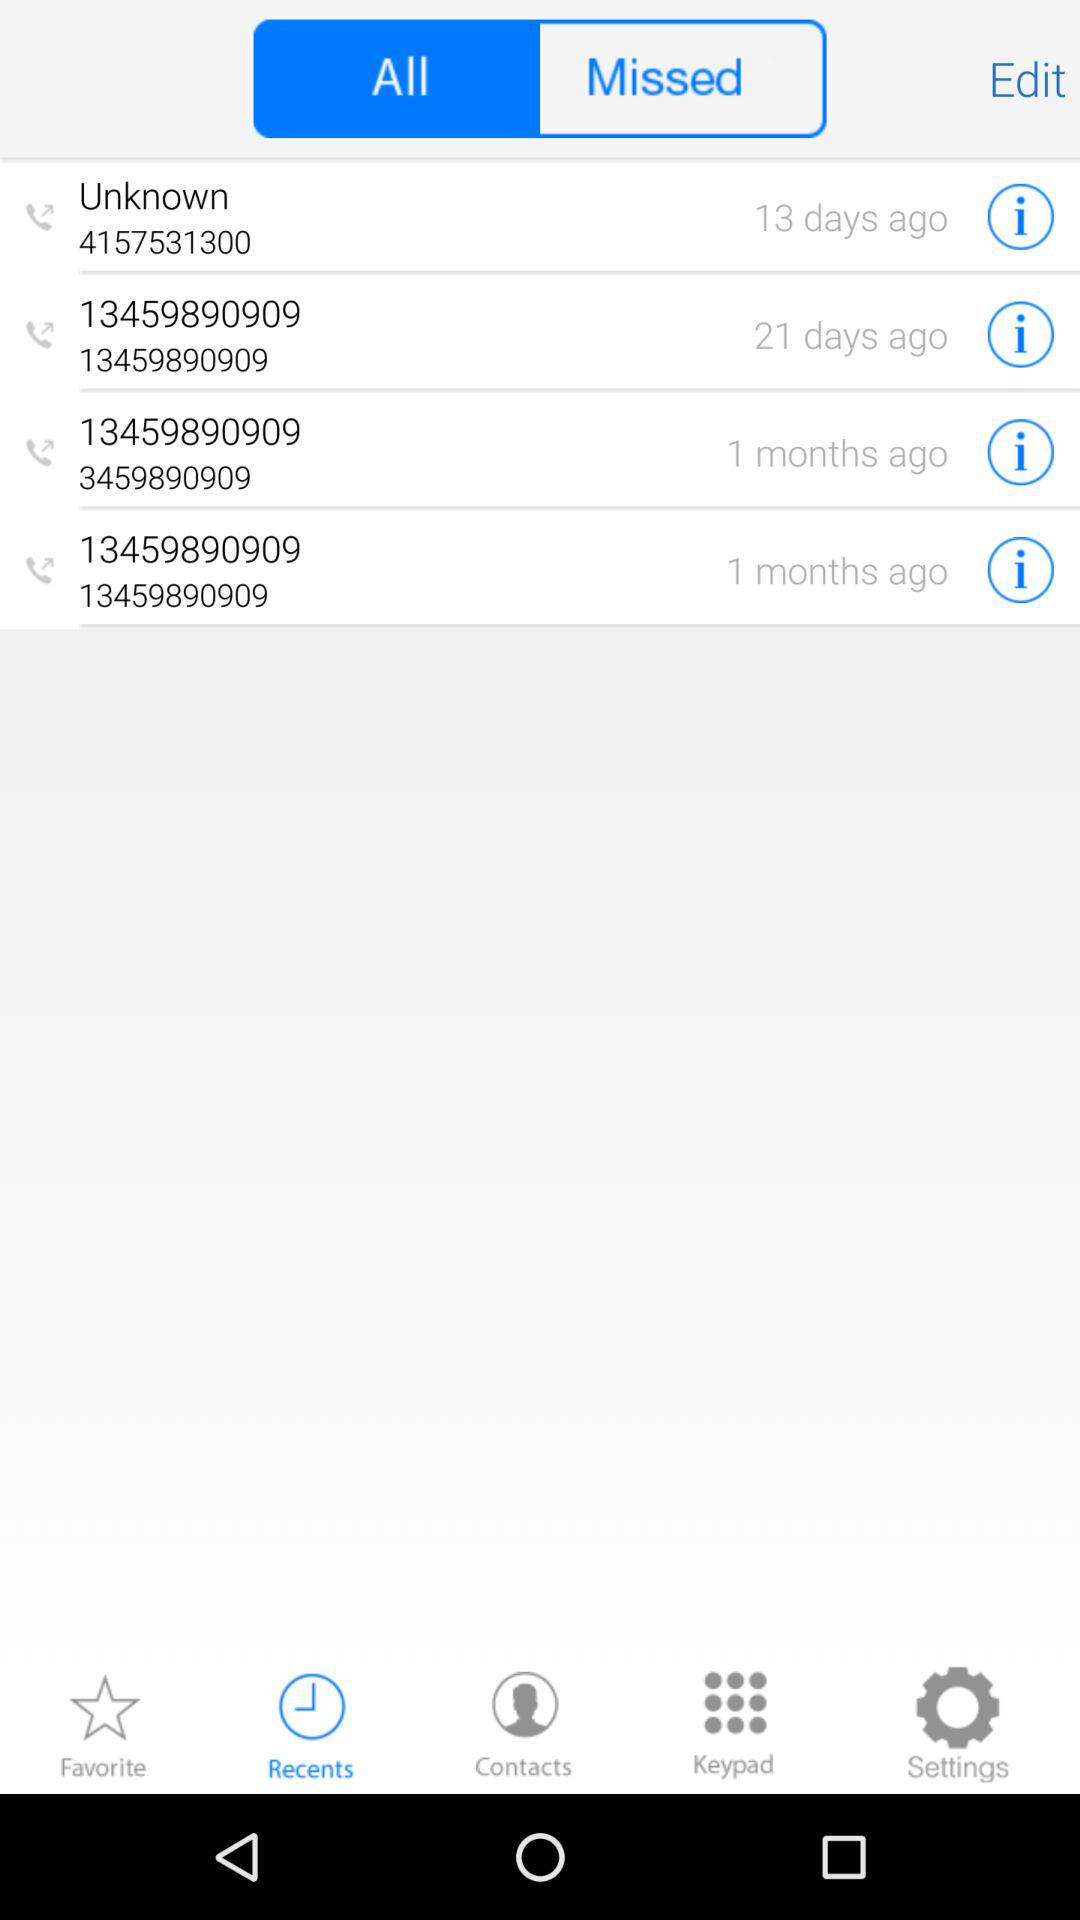Which tab are we on? You are on the "Recents" and "All" tabs. 